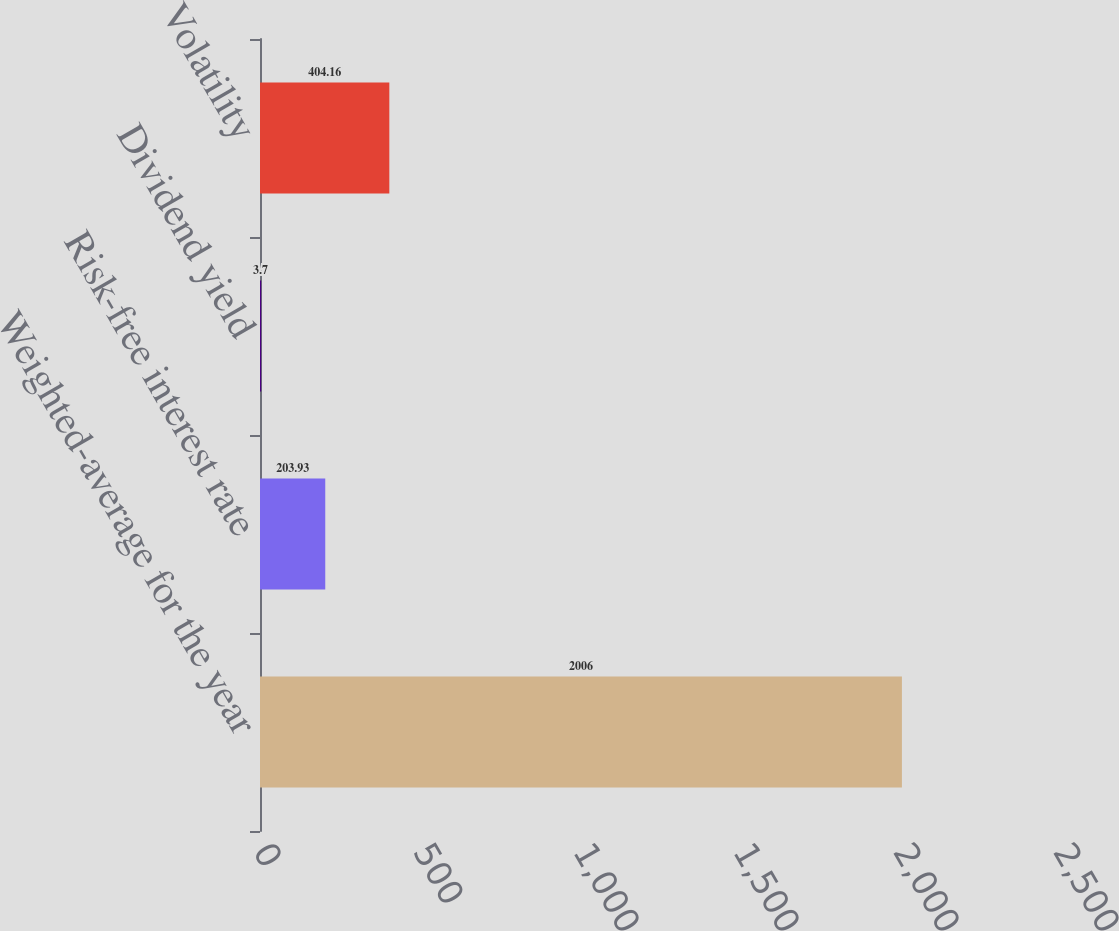Convert chart. <chart><loc_0><loc_0><loc_500><loc_500><bar_chart><fcel>Weighted-average for the year<fcel>Risk-free interest rate<fcel>Dividend yield<fcel>Volatility<nl><fcel>2006<fcel>203.93<fcel>3.7<fcel>404.16<nl></chart> 